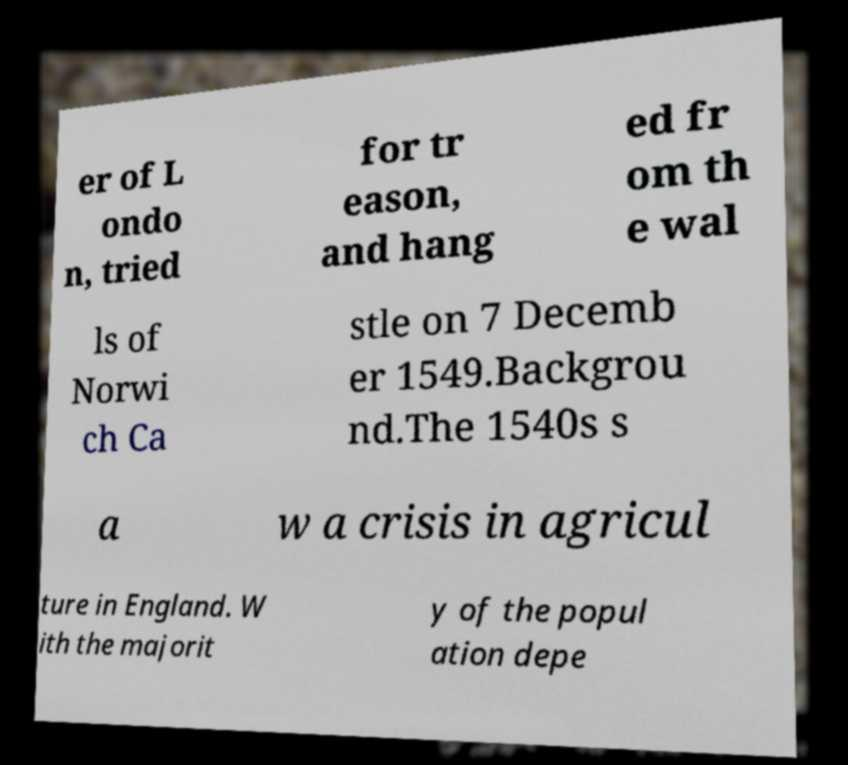Could you assist in decoding the text presented in this image and type it out clearly? er of L ondo n, tried for tr eason, and hang ed fr om th e wal ls of Norwi ch Ca stle on 7 Decemb er 1549.Backgrou nd.The 1540s s a w a crisis in agricul ture in England. W ith the majorit y of the popul ation depe 